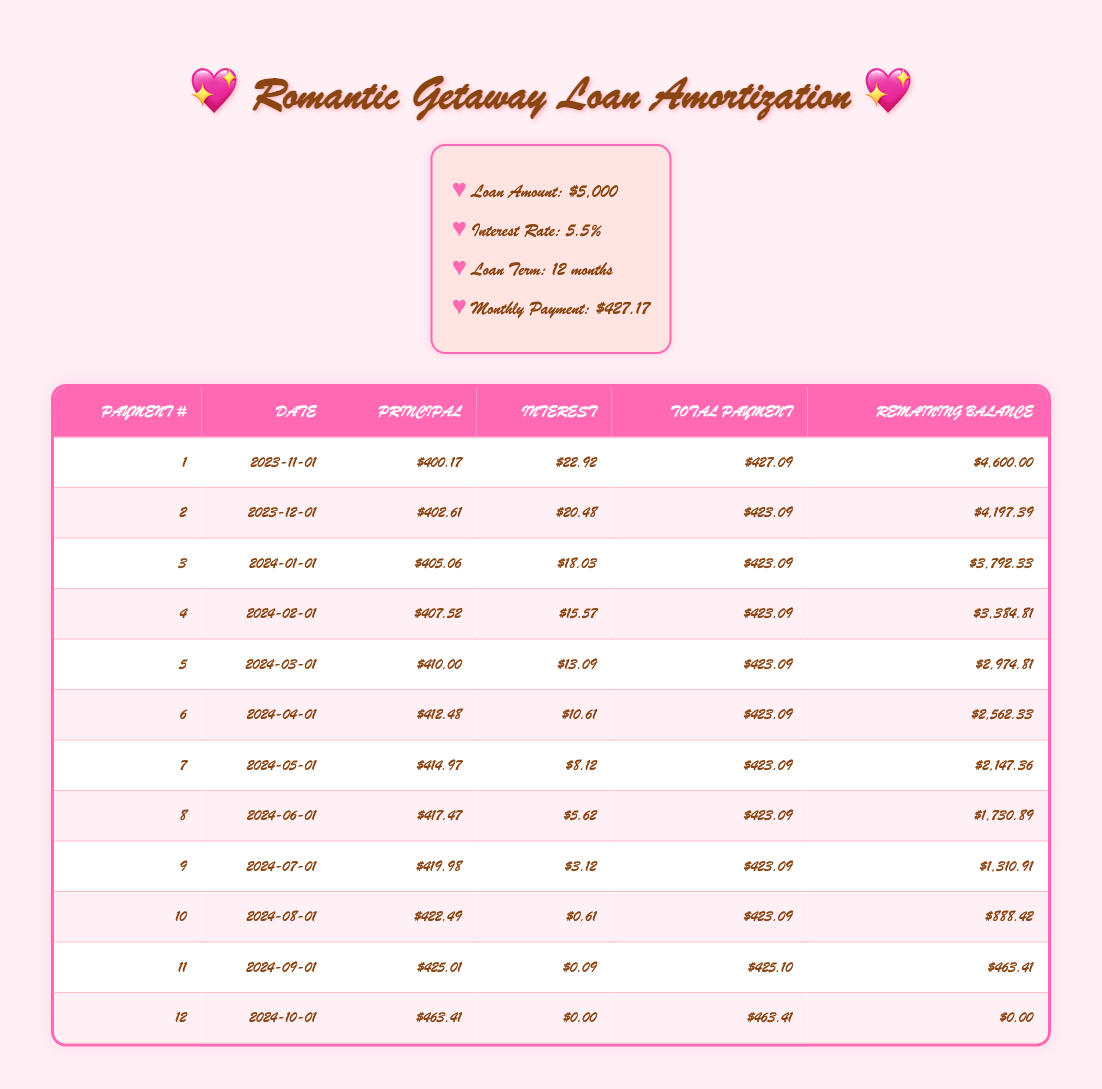What is the total amount paid over the course of the loan? The monthly payment is $427.17, and there are 12 payments in total. To find the total amount paid, multiply the monthly payment by the number of payments: 427.17 * 12 = 5,126.04.
Answer: 5,126.04 What is the remaining balance after the 6th payment? According to the amortization schedule, after the 6th payment, the remaining balance is listed as $2,562.33.
Answer: 2,562.33 What is the interest payment for the first month? In the table, for the first payment, the interest payment is recorded as $22.92.
Answer: 22.92 Is the total payment for the 11th payment greater than the total payment for the 10th payment? The total payment for the 11th payment is $425.10, and for the 10th payment, it is $423.09. Since $425.10 is greater than $423.09, the statement is true.
Answer: Yes What is the difference in principal payment between the 2nd and 3rd payments? The principal payment for the 2nd payment is $402.61, and for the 3rd payment, it is $405.06. To find the difference, subtract the 2nd principal from the 3rd: 405.06 - 402.61 = 2.45.
Answer: 2.45 On which date was the last payment made? The last payment is recorded in the 12th row of the table, and the date listed is 2024-10-01.
Answer: 2024-10-01 What is the average principal payment over the loan term? To find the average principal payment, sum all the principal payments from month 1 to month 12, which gives 400.17 + 402.61 + 405.06 + 407.52 + 410.00 + 412.48 + 414.97 + 417.47 + 419.98 + 422.49 + 425.01 + 463.41 = 4,922.17. Then divide by 12: 4,922.17 / 12 ≈ 410.18.
Answer: 410.18 How much interest was paid in total by the end of the loan? To find the total interest paid over the loan term, sum all the interest payments: 22.92 + 20.48 + 18.03 + 15.57 + 13.09 + 10.61 + 8.12 + 5.62 + 3.12 + 0.61 + 0.09 + 0.00 = 108.74.
Answer: 108.74 What is the principal payment amount for the 5th payment? The table shows that the principal payment for the 5th payment is $410.00.
Answer: 410.00 